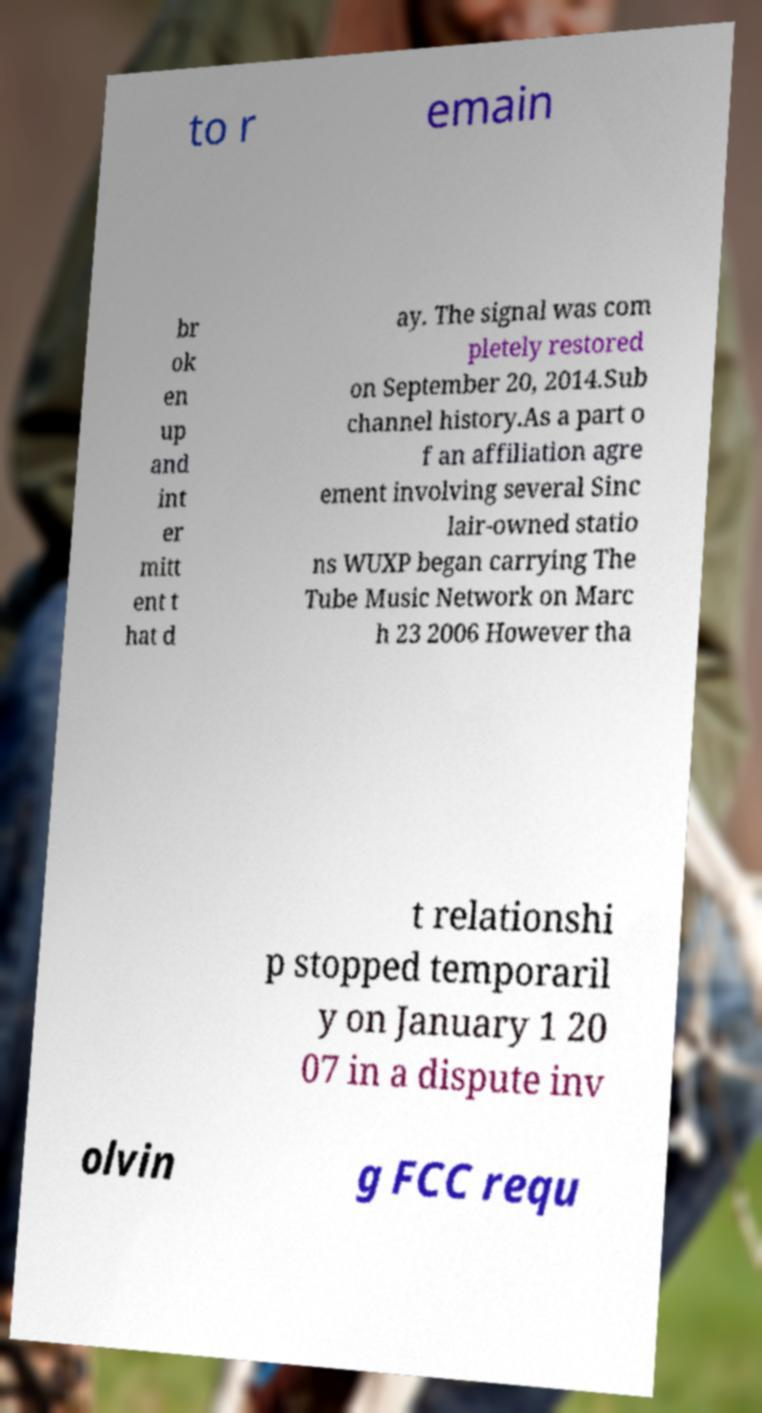What messages or text are displayed in this image? I need them in a readable, typed format. to r emain br ok en up and int er mitt ent t hat d ay. The signal was com pletely restored on September 20, 2014.Sub channel history.As a part o f an affiliation agre ement involving several Sinc lair-owned statio ns WUXP began carrying The Tube Music Network on Marc h 23 2006 However tha t relationshi p stopped temporaril y on January 1 20 07 in a dispute inv olvin g FCC requ 